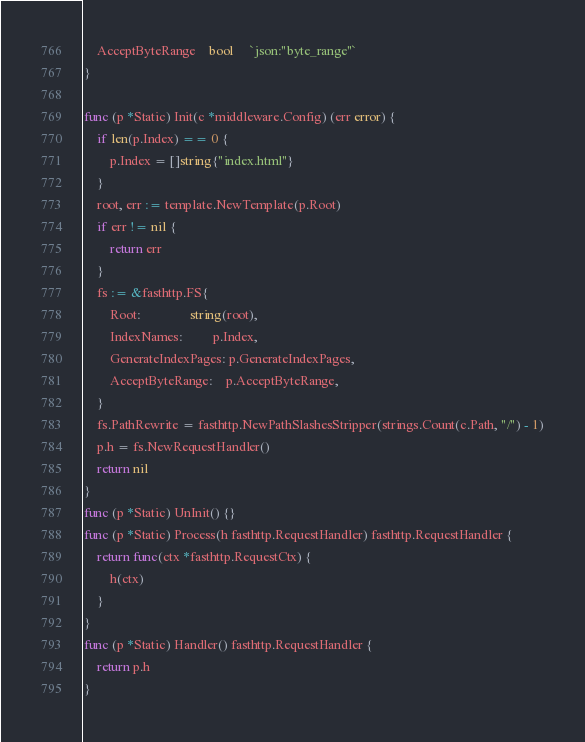<code> <loc_0><loc_0><loc_500><loc_500><_Go_>	AcceptByteRange    bool     `json:"byte_range"`
}

func (p *Static) Init(c *middleware.Config) (err error) {
	if len(p.Index) == 0 {
		p.Index = []string{"index.html"}
	}
	root, err := template.NewTemplate(p.Root)
	if err != nil {
		return err
	}
	fs := &fasthttp.FS{
		Root:               string(root),
		IndexNames:         p.Index,
		GenerateIndexPages: p.GenerateIndexPages,
		AcceptByteRange:    p.AcceptByteRange,
	}
	fs.PathRewrite = fasthttp.NewPathSlashesStripper(strings.Count(c.Path, "/") - 1)
	p.h = fs.NewRequestHandler()
	return nil
}
func (p *Static) UnInit() {}
func (p *Static) Process(h fasthttp.RequestHandler) fasthttp.RequestHandler {
	return func(ctx *fasthttp.RequestCtx) {
		h(ctx)
	}
}
func (p *Static) Handler() fasthttp.RequestHandler {
	return p.h
}
</code> 